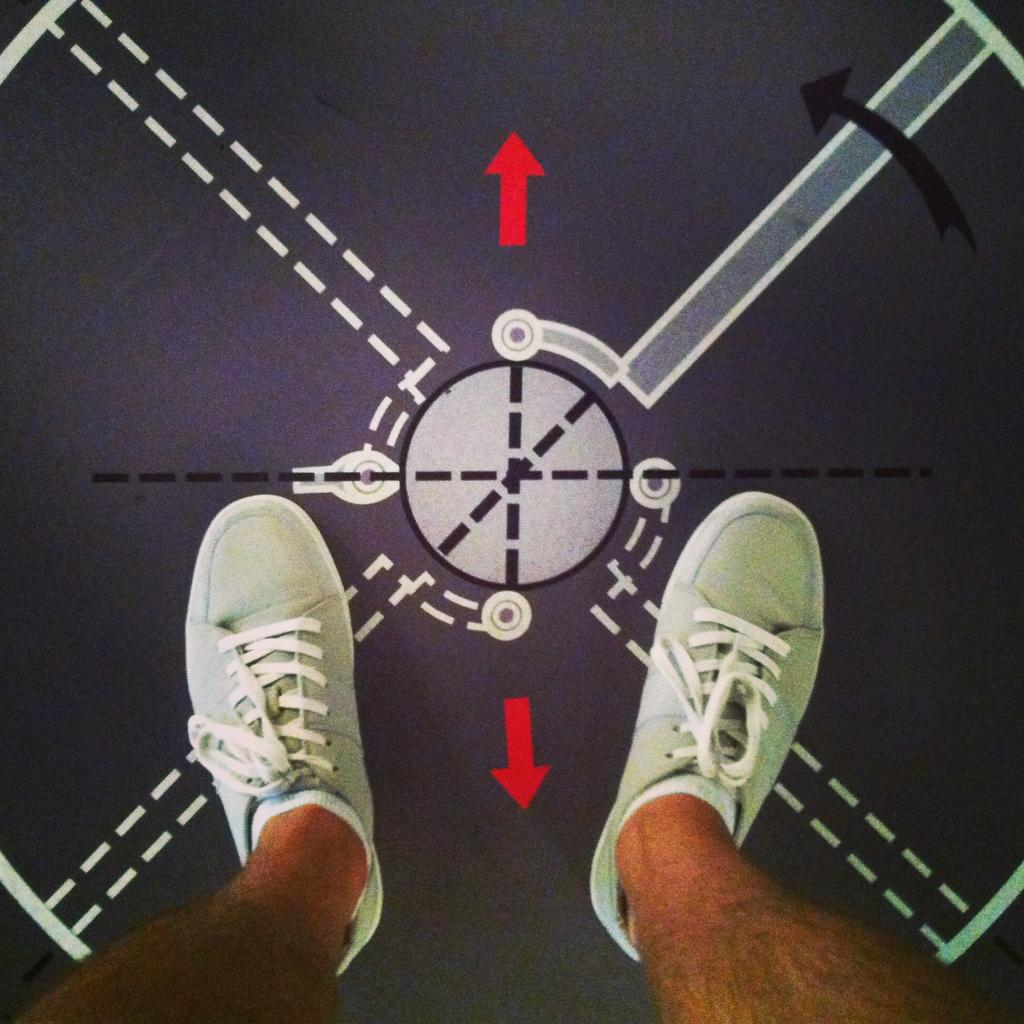Who or what is the main subject in the image? There is a person in the image. What part of the person's body can be seen? The person's legs are visible. What color are the shoes the person is wearing? The person is wearing green color shoes. Can you describe any shapes or objects in the background of the image? There is a circle shape ring in the background of the image. What level of education does the baby in the image have? There is no baby present in the image, so it is not possible to determine their level of education. 